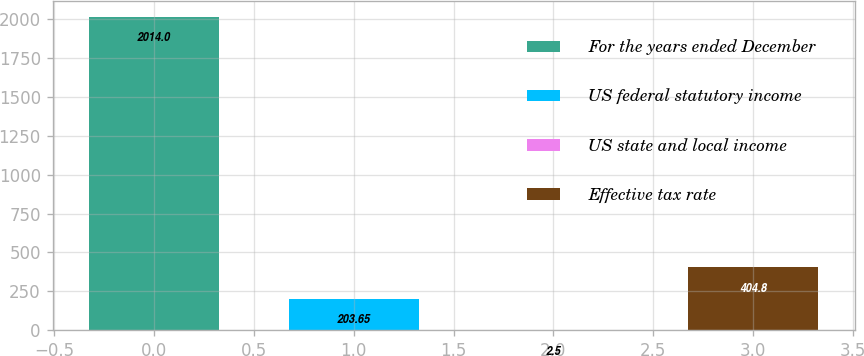Convert chart to OTSL. <chart><loc_0><loc_0><loc_500><loc_500><bar_chart><fcel>For the years ended December<fcel>US federal statutory income<fcel>US state and local income<fcel>Effective tax rate<nl><fcel>2014<fcel>203.65<fcel>2.5<fcel>404.8<nl></chart> 